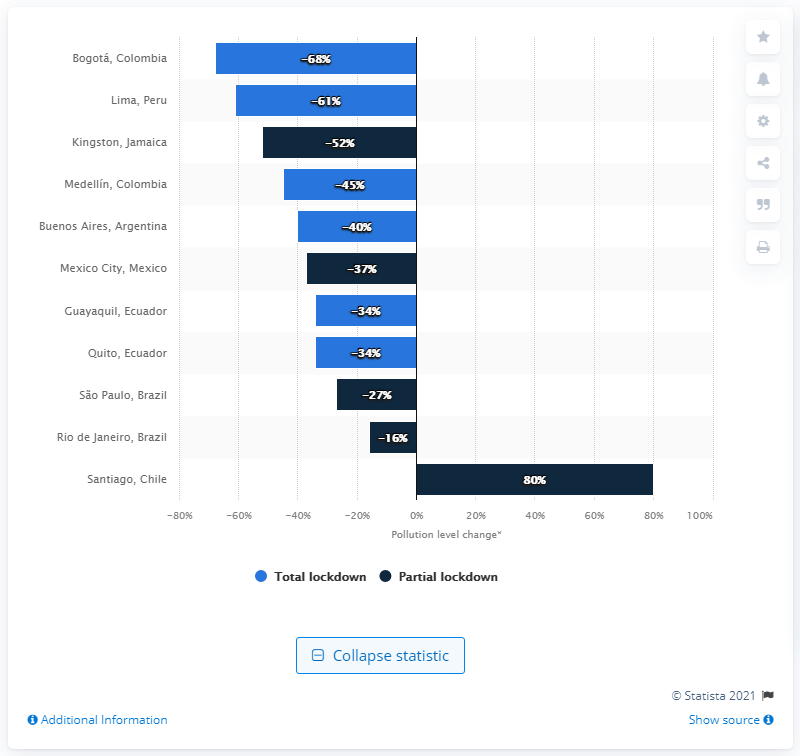Outline some significant characteristics in this image. The increase in air pollution in Santiago, Chile was 80%. 